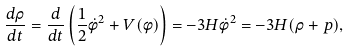Convert formula to latex. <formula><loc_0><loc_0><loc_500><loc_500>\frac { d \rho } { d t } = \frac { d } { d t } \left ( \frac { 1 } { 2 } \dot { \phi } ^ { 2 } + V ( \phi ) \right ) = - 3 H \dot { \phi } ^ { 2 } = - 3 H ( \rho + p ) ,</formula> 